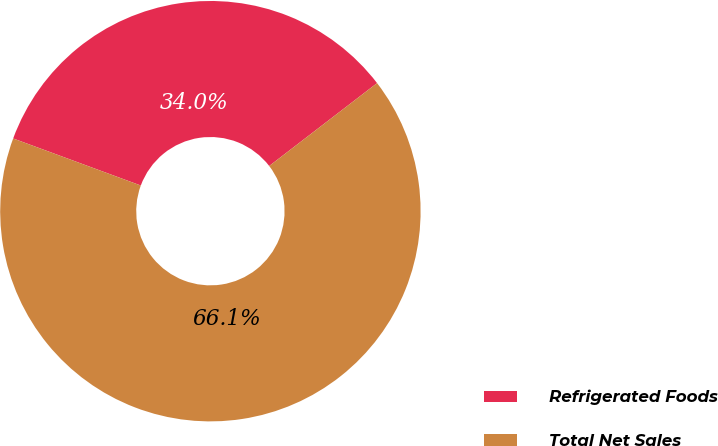<chart> <loc_0><loc_0><loc_500><loc_500><pie_chart><fcel>Refrigerated Foods<fcel>Total Net Sales<nl><fcel>33.95%<fcel>66.05%<nl></chart> 